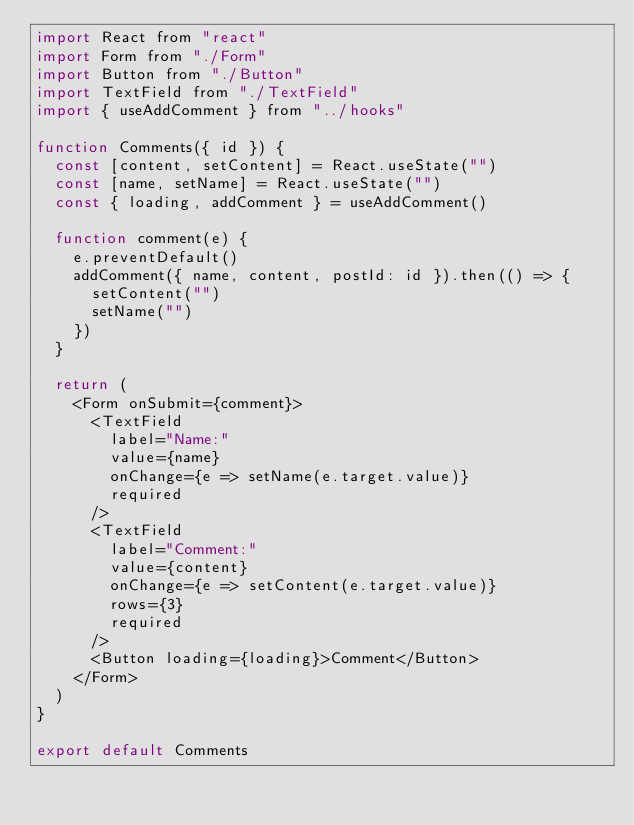Convert code to text. <code><loc_0><loc_0><loc_500><loc_500><_JavaScript_>import React from "react"
import Form from "./Form"
import Button from "./Button"
import TextField from "./TextField"
import { useAddComment } from "../hooks"

function Comments({ id }) {
  const [content, setContent] = React.useState("")
  const [name, setName] = React.useState("")
  const { loading, addComment } = useAddComment()

  function comment(e) {
    e.preventDefault()
    addComment({ name, content, postId: id }).then(() => {
      setContent("")
      setName("")
    })
  }

  return (
    <Form onSubmit={comment}>
      <TextField
        label="Name:"
        value={name}
        onChange={e => setName(e.target.value)}
        required
      />
      <TextField
        label="Comment:"
        value={content}
        onChange={e => setContent(e.target.value)}
        rows={3}
        required
      />
      <Button loading={loading}>Comment</Button>
    </Form>
  )
}

export default Comments
</code> 